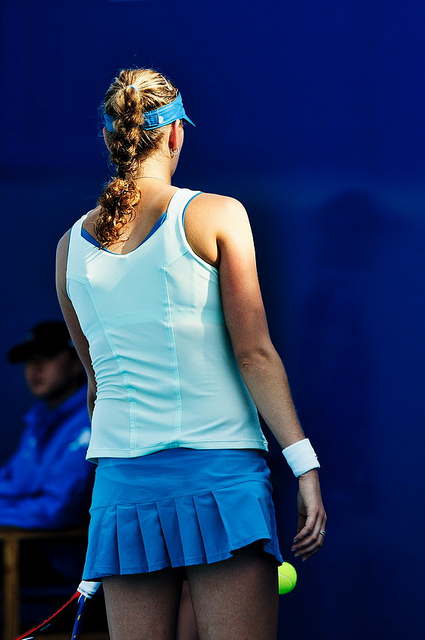<image>What brand is her skirt? I don't know the brand of her skirt. It could be either Adidas, Nike or Sony. What brand is her skirt? I am not sure what brand her skirt is. It can be seen Adidas, Nike or Sony. 